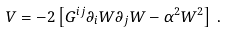<formula> <loc_0><loc_0><loc_500><loc_500>V = - 2 \left [ G ^ { i j } \partial _ { i } W \partial _ { j } W - \alpha ^ { 2 } W ^ { 2 } \right ] \, .</formula> 